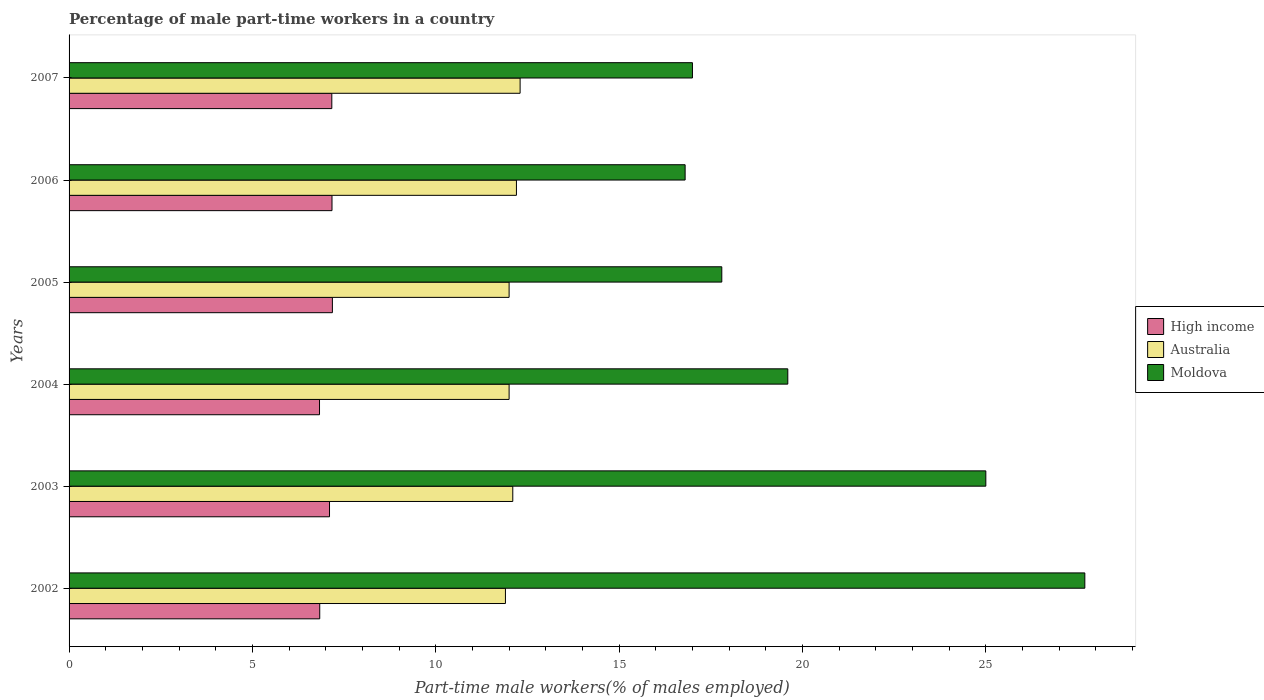How many different coloured bars are there?
Your response must be concise. 3. How many groups of bars are there?
Make the answer very short. 6. Are the number of bars on each tick of the Y-axis equal?
Give a very brief answer. Yes. How many bars are there on the 2nd tick from the bottom?
Give a very brief answer. 3. What is the label of the 3rd group of bars from the top?
Ensure brevity in your answer.  2005. In how many cases, is the number of bars for a given year not equal to the number of legend labels?
Provide a short and direct response. 0. What is the percentage of male part-time workers in Moldova in 2002?
Your answer should be very brief. 27.7. Across all years, what is the maximum percentage of male part-time workers in Moldova?
Your answer should be very brief. 27.7. Across all years, what is the minimum percentage of male part-time workers in Australia?
Keep it short and to the point. 11.9. What is the total percentage of male part-time workers in High income in the graph?
Provide a succinct answer. 42.28. What is the difference between the percentage of male part-time workers in High income in 2002 and that in 2005?
Provide a succinct answer. -0.34. What is the difference between the percentage of male part-time workers in Moldova in 2005 and the percentage of male part-time workers in High income in 2003?
Ensure brevity in your answer.  10.7. What is the average percentage of male part-time workers in Moldova per year?
Ensure brevity in your answer.  20.65. In the year 2002, what is the difference between the percentage of male part-time workers in Australia and percentage of male part-time workers in High income?
Provide a short and direct response. 5.06. In how many years, is the percentage of male part-time workers in Moldova greater than 23 %?
Your answer should be very brief. 2. What is the ratio of the percentage of male part-time workers in High income in 2005 to that in 2006?
Ensure brevity in your answer.  1. Is the difference between the percentage of male part-time workers in Australia in 2003 and 2007 greater than the difference between the percentage of male part-time workers in High income in 2003 and 2007?
Your response must be concise. No. What is the difference between the highest and the second highest percentage of male part-time workers in Moldova?
Your answer should be very brief. 2.7. What is the difference between the highest and the lowest percentage of male part-time workers in Moldova?
Your answer should be compact. 10.9. What does the 2nd bar from the bottom in 2007 represents?
Your response must be concise. Australia. How many bars are there?
Your answer should be compact. 18. Are all the bars in the graph horizontal?
Your answer should be compact. Yes. Are the values on the major ticks of X-axis written in scientific E-notation?
Ensure brevity in your answer.  No. Does the graph contain any zero values?
Offer a very short reply. No. Where does the legend appear in the graph?
Your answer should be very brief. Center right. How are the legend labels stacked?
Offer a terse response. Vertical. What is the title of the graph?
Your answer should be compact. Percentage of male part-time workers in a country. Does "Arab World" appear as one of the legend labels in the graph?
Give a very brief answer. No. What is the label or title of the X-axis?
Your answer should be very brief. Part-time male workers(% of males employed). What is the label or title of the Y-axis?
Your response must be concise. Years. What is the Part-time male workers(% of males employed) of High income in 2002?
Ensure brevity in your answer.  6.84. What is the Part-time male workers(% of males employed) in Australia in 2002?
Provide a succinct answer. 11.9. What is the Part-time male workers(% of males employed) of Moldova in 2002?
Your answer should be compact. 27.7. What is the Part-time male workers(% of males employed) of High income in 2003?
Your answer should be very brief. 7.1. What is the Part-time male workers(% of males employed) of Australia in 2003?
Ensure brevity in your answer.  12.1. What is the Part-time male workers(% of males employed) of Moldova in 2003?
Provide a short and direct response. 25. What is the Part-time male workers(% of males employed) of High income in 2004?
Give a very brief answer. 6.83. What is the Part-time male workers(% of males employed) in Australia in 2004?
Your answer should be very brief. 12. What is the Part-time male workers(% of males employed) of Moldova in 2004?
Your answer should be very brief. 19.6. What is the Part-time male workers(% of males employed) in High income in 2005?
Make the answer very short. 7.18. What is the Part-time male workers(% of males employed) of Australia in 2005?
Ensure brevity in your answer.  12. What is the Part-time male workers(% of males employed) in Moldova in 2005?
Provide a succinct answer. 17.8. What is the Part-time male workers(% of males employed) of High income in 2006?
Give a very brief answer. 7.17. What is the Part-time male workers(% of males employed) in Australia in 2006?
Provide a succinct answer. 12.2. What is the Part-time male workers(% of males employed) in Moldova in 2006?
Make the answer very short. 16.8. What is the Part-time male workers(% of males employed) of High income in 2007?
Make the answer very short. 7.16. What is the Part-time male workers(% of males employed) in Australia in 2007?
Keep it short and to the point. 12.3. Across all years, what is the maximum Part-time male workers(% of males employed) in High income?
Offer a very short reply. 7.18. Across all years, what is the maximum Part-time male workers(% of males employed) in Australia?
Your answer should be compact. 12.3. Across all years, what is the maximum Part-time male workers(% of males employed) in Moldova?
Your response must be concise. 27.7. Across all years, what is the minimum Part-time male workers(% of males employed) of High income?
Provide a short and direct response. 6.83. Across all years, what is the minimum Part-time male workers(% of males employed) of Australia?
Give a very brief answer. 11.9. Across all years, what is the minimum Part-time male workers(% of males employed) of Moldova?
Make the answer very short. 16.8. What is the total Part-time male workers(% of males employed) in High income in the graph?
Give a very brief answer. 42.28. What is the total Part-time male workers(% of males employed) in Australia in the graph?
Provide a short and direct response. 72.5. What is the total Part-time male workers(% of males employed) in Moldova in the graph?
Ensure brevity in your answer.  123.9. What is the difference between the Part-time male workers(% of males employed) of High income in 2002 and that in 2003?
Keep it short and to the point. -0.27. What is the difference between the Part-time male workers(% of males employed) in Australia in 2002 and that in 2003?
Ensure brevity in your answer.  -0.2. What is the difference between the Part-time male workers(% of males employed) in High income in 2002 and that in 2004?
Your response must be concise. 0.01. What is the difference between the Part-time male workers(% of males employed) in Australia in 2002 and that in 2004?
Offer a terse response. -0.1. What is the difference between the Part-time male workers(% of males employed) in High income in 2002 and that in 2005?
Offer a very short reply. -0.34. What is the difference between the Part-time male workers(% of males employed) in Australia in 2002 and that in 2005?
Your answer should be compact. -0.1. What is the difference between the Part-time male workers(% of males employed) of Moldova in 2002 and that in 2005?
Offer a terse response. 9.9. What is the difference between the Part-time male workers(% of males employed) in High income in 2002 and that in 2006?
Provide a succinct answer. -0.33. What is the difference between the Part-time male workers(% of males employed) in Australia in 2002 and that in 2006?
Make the answer very short. -0.3. What is the difference between the Part-time male workers(% of males employed) in High income in 2002 and that in 2007?
Your response must be concise. -0.33. What is the difference between the Part-time male workers(% of males employed) in Australia in 2002 and that in 2007?
Your answer should be compact. -0.4. What is the difference between the Part-time male workers(% of males employed) of Moldova in 2002 and that in 2007?
Offer a very short reply. 10.7. What is the difference between the Part-time male workers(% of males employed) of High income in 2003 and that in 2004?
Make the answer very short. 0.27. What is the difference between the Part-time male workers(% of males employed) in Australia in 2003 and that in 2004?
Keep it short and to the point. 0.1. What is the difference between the Part-time male workers(% of males employed) in Moldova in 2003 and that in 2004?
Make the answer very short. 5.4. What is the difference between the Part-time male workers(% of males employed) in High income in 2003 and that in 2005?
Keep it short and to the point. -0.08. What is the difference between the Part-time male workers(% of males employed) in Australia in 2003 and that in 2005?
Offer a terse response. 0.1. What is the difference between the Part-time male workers(% of males employed) of Moldova in 2003 and that in 2005?
Give a very brief answer. 7.2. What is the difference between the Part-time male workers(% of males employed) of High income in 2003 and that in 2006?
Keep it short and to the point. -0.07. What is the difference between the Part-time male workers(% of males employed) of High income in 2003 and that in 2007?
Your answer should be compact. -0.06. What is the difference between the Part-time male workers(% of males employed) in High income in 2004 and that in 2005?
Make the answer very short. -0.35. What is the difference between the Part-time male workers(% of males employed) of Moldova in 2004 and that in 2005?
Your response must be concise. 1.8. What is the difference between the Part-time male workers(% of males employed) in High income in 2004 and that in 2006?
Make the answer very short. -0.34. What is the difference between the Part-time male workers(% of males employed) in Australia in 2004 and that in 2006?
Your response must be concise. -0.2. What is the difference between the Part-time male workers(% of males employed) of High income in 2004 and that in 2007?
Ensure brevity in your answer.  -0.34. What is the difference between the Part-time male workers(% of males employed) of Australia in 2004 and that in 2007?
Offer a very short reply. -0.3. What is the difference between the Part-time male workers(% of males employed) in High income in 2005 and that in 2006?
Offer a terse response. 0.01. What is the difference between the Part-time male workers(% of males employed) in Moldova in 2005 and that in 2006?
Your response must be concise. 1. What is the difference between the Part-time male workers(% of males employed) in High income in 2005 and that in 2007?
Give a very brief answer. 0.02. What is the difference between the Part-time male workers(% of males employed) in High income in 2006 and that in 2007?
Provide a short and direct response. 0.01. What is the difference between the Part-time male workers(% of males employed) in High income in 2002 and the Part-time male workers(% of males employed) in Australia in 2003?
Your response must be concise. -5.26. What is the difference between the Part-time male workers(% of males employed) of High income in 2002 and the Part-time male workers(% of males employed) of Moldova in 2003?
Offer a terse response. -18.16. What is the difference between the Part-time male workers(% of males employed) of High income in 2002 and the Part-time male workers(% of males employed) of Australia in 2004?
Keep it short and to the point. -5.16. What is the difference between the Part-time male workers(% of males employed) of High income in 2002 and the Part-time male workers(% of males employed) of Moldova in 2004?
Give a very brief answer. -12.76. What is the difference between the Part-time male workers(% of males employed) in High income in 2002 and the Part-time male workers(% of males employed) in Australia in 2005?
Ensure brevity in your answer.  -5.16. What is the difference between the Part-time male workers(% of males employed) in High income in 2002 and the Part-time male workers(% of males employed) in Moldova in 2005?
Keep it short and to the point. -10.96. What is the difference between the Part-time male workers(% of males employed) in High income in 2002 and the Part-time male workers(% of males employed) in Australia in 2006?
Offer a terse response. -5.36. What is the difference between the Part-time male workers(% of males employed) of High income in 2002 and the Part-time male workers(% of males employed) of Moldova in 2006?
Your answer should be compact. -9.96. What is the difference between the Part-time male workers(% of males employed) in Australia in 2002 and the Part-time male workers(% of males employed) in Moldova in 2006?
Keep it short and to the point. -4.9. What is the difference between the Part-time male workers(% of males employed) of High income in 2002 and the Part-time male workers(% of males employed) of Australia in 2007?
Ensure brevity in your answer.  -5.46. What is the difference between the Part-time male workers(% of males employed) in High income in 2002 and the Part-time male workers(% of males employed) in Moldova in 2007?
Provide a succinct answer. -10.16. What is the difference between the Part-time male workers(% of males employed) of High income in 2003 and the Part-time male workers(% of males employed) of Australia in 2004?
Keep it short and to the point. -4.9. What is the difference between the Part-time male workers(% of males employed) of High income in 2003 and the Part-time male workers(% of males employed) of Moldova in 2004?
Offer a very short reply. -12.5. What is the difference between the Part-time male workers(% of males employed) of High income in 2003 and the Part-time male workers(% of males employed) of Australia in 2005?
Make the answer very short. -4.9. What is the difference between the Part-time male workers(% of males employed) of High income in 2003 and the Part-time male workers(% of males employed) of Moldova in 2005?
Your answer should be compact. -10.7. What is the difference between the Part-time male workers(% of males employed) in Australia in 2003 and the Part-time male workers(% of males employed) in Moldova in 2005?
Keep it short and to the point. -5.7. What is the difference between the Part-time male workers(% of males employed) of High income in 2003 and the Part-time male workers(% of males employed) of Australia in 2006?
Provide a short and direct response. -5.1. What is the difference between the Part-time male workers(% of males employed) of High income in 2003 and the Part-time male workers(% of males employed) of Moldova in 2006?
Your answer should be very brief. -9.7. What is the difference between the Part-time male workers(% of males employed) of Australia in 2003 and the Part-time male workers(% of males employed) of Moldova in 2006?
Make the answer very short. -4.7. What is the difference between the Part-time male workers(% of males employed) of High income in 2003 and the Part-time male workers(% of males employed) of Australia in 2007?
Your answer should be compact. -5.2. What is the difference between the Part-time male workers(% of males employed) in High income in 2003 and the Part-time male workers(% of males employed) in Moldova in 2007?
Give a very brief answer. -9.9. What is the difference between the Part-time male workers(% of males employed) of Australia in 2003 and the Part-time male workers(% of males employed) of Moldova in 2007?
Ensure brevity in your answer.  -4.9. What is the difference between the Part-time male workers(% of males employed) of High income in 2004 and the Part-time male workers(% of males employed) of Australia in 2005?
Your answer should be very brief. -5.17. What is the difference between the Part-time male workers(% of males employed) of High income in 2004 and the Part-time male workers(% of males employed) of Moldova in 2005?
Give a very brief answer. -10.97. What is the difference between the Part-time male workers(% of males employed) in Australia in 2004 and the Part-time male workers(% of males employed) in Moldova in 2005?
Provide a short and direct response. -5.8. What is the difference between the Part-time male workers(% of males employed) of High income in 2004 and the Part-time male workers(% of males employed) of Australia in 2006?
Offer a terse response. -5.37. What is the difference between the Part-time male workers(% of males employed) in High income in 2004 and the Part-time male workers(% of males employed) in Moldova in 2006?
Offer a very short reply. -9.97. What is the difference between the Part-time male workers(% of males employed) in High income in 2004 and the Part-time male workers(% of males employed) in Australia in 2007?
Give a very brief answer. -5.47. What is the difference between the Part-time male workers(% of males employed) of High income in 2004 and the Part-time male workers(% of males employed) of Moldova in 2007?
Provide a short and direct response. -10.17. What is the difference between the Part-time male workers(% of males employed) of Australia in 2004 and the Part-time male workers(% of males employed) of Moldova in 2007?
Provide a succinct answer. -5. What is the difference between the Part-time male workers(% of males employed) in High income in 2005 and the Part-time male workers(% of males employed) in Australia in 2006?
Ensure brevity in your answer.  -5.02. What is the difference between the Part-time male workers(% of males employed) in High income in 2005 and the Part-time male workers(% of males employed) in Moldova in 2006?
Keep it short and to the point. -9.62. What is the difference between the Part-time male workers(% of males employed) in High income in 2005 and the Part-time male workers(% of males employed) in Australia in 2007?
Your response must be concise. -5.12. What is the difference between the Part-time male workers(% of males employed) in High income in 2005 and the Part-time male workers(% of males employed) in Moldova in 2007?
Provide a succinct answer. -9.82. What is the difference between the Part-time male workers(% of males employed) of Australia in 2005 and the Part-time male workers(% of males employed) of Moldova in 2007?
Make the answer very short. -5. What is the difference between the Part-time male workers(% of males employed) of High income in 2006 and the Part-time male workers(% of males employed) of Australia in 2007?
Offer a very short reply. -5.13. What is the difference between the Part-time male workers(% of males employed) of High income in 2006 and the Part-time male workers(% of males employed) of Moldova in 2007?
Offer a very short reply. -9.83. What is the average Part-time male workers(% of males employed) of High income per year?
Offer a very short reply. 7.05. What is the average Part-time male workers(% of males employed) in Australia per year?
Provide a succinct answer. 12.08. What is the average Part-time male workers(% of males employed) of Moldova per year?
Offer a terse response. 20.65. In the year 2002, what is the difference between the Part-time male workers(% of males employed) of High income and Part-time male workers(% of males employed) of Australia?
Provide a succinct answer. -5.06. In the year 2002, what is the difference between the Part-time male workers(% of males employed) in High income and Part-time male workers(% of males employed) in Moldova?
Keep it short and to the point. -20.86. In the year 2002, what is the difference between the Part-time male workers(% of males employed) of Australia and Part-time male workers(% of males employed) of Moldova?
Your answer should be very brief. -15.8. In the year 2003, what is the difference between the Part-time male workers(% of males employed) in High income and Part-time male workers(% of males employed) in Australia?
Offer a terse response. -5. In the year 2003, what is the difference between the Part-time male workers(% of males employed) in High income and Part-time male workers(% of males employed) in Moldova?
Give a very brief answer. -17.9. In the year 2004, what is the difference between the Part-time male workers(% of males employed) of High income and Part-time male workers(% of males employed) of Australia?
Provide a short and direct response. -5.17. In the year 2004, what is the difference between the Part-time male workers(% of males employed) of High income and Part-time male workers(% of males employed) of Moldova?
Your response must be concise. -12.77. In the year 2004, what is the difference between the Part-time male workers(% of males employed) in Australia and Part-time male workers(% of males employed) in Moldova?
Keep it short and to the point. -7.6. In the year 2005, what is the difference between the Part-time male workers(% of males employed) in High income and Part-time male workers(% of males employed) in Australia?
Give a very brief answer. -4.82. In the year 2005, what is the difference between the Part-time male workers(% of males employed) of High income and Part-time male workers(% of males employed) of Moldova?
Provide a short and direct response. -10.62. In the year 2005, what is the difference between the Part-time male workers(% of males employed) of Australia and Part-time male workers(% of males employed) of Moldova?
Offer a very short reply. -5.8. In the year 2006, what is the difference between the Part-time male workers(% of males employed) in High income and Part-time male workers(% of males employed) in Australia?
Make the answer very short. -5.03. In the year 2006, what is the difference between the Part-time male workers(% of males employed) in High income and Part-time male workers(% of males employed) in Moldova?
Offer a very short reply. -9.63. In the year 2007, what is the difference between the Part-time male workers(% of males employed) of High income and Part-time male workers(% of males employed) of Australia?
Keep it short and to the point. -5.13. In the year 2007, what is the difference between the Part-time male workers(% of males employed) in High income and Part-time male workers(% of males employed) in Moldova?
Your response must be concise. -9.84. In the year 2007, what is the difference between the Part-time male workers(% of males employed) of Australia and Part-time male workers(% of males employed) of Moldova?
Your answer should be very brief. -4.7. What is the ratio of the Part-time male workers(% of males employed) of High income in 2002 to that in 2003?
Make the answer very short. 0.96. What is the ratio of the Part-time male workers(% of males employed) in Australia in 2002 to that in 2003?
Your response must be concise. 0.98. What is the ratio of the Part-time male workers(% of males employed) of Moldova in 2002 to that in 2003?
Your response must be concise. 1.11. What is the ratio of the Part-time male workers(% of males employed) in High income in 2002 to that in 2004?
Make the answer very short. 1. What is the ratio of the Part-time male workers(% of males employed) of Moldova in 2002 to that in 2004?
Make the answer very short. 1.41. What is the ratio of the Part-time male workers(% of males employed) in High income in 2002 to that in 2005?
Your answer should be very brief. 0.95. What is the ratio of the Part-time male workers(% of males employed) in Australia in 2002 to that in 2005?
Your response must be concise. 0.99. What is the ratio of the Part-time male workers(% of males employed) in Moldova in 2002 to that in 2005?
Keep it short and to the point. 1.56. What is the ratio of the Part-time male workers(% of males employed) of High income in 2002 to that in 2006?
Your answer should be compact. 0.95. What is the ratio of the Part-time male workers(% of males employed) in Australia in 2002 to that in 2006?
Make the answer very short. 0.98. What is the ratio of the Part-time male workers(% of males employed) of Moldova in 2002 to that in 2006?
Offer a very short reply. 1.65. What is the ratio of the Part-time male workers(% of males employed) in High income in 2002 to that in 2007?
Provide a short and direct response. 0.95. What is the ratio of the Part-time male workers(% of males employed) in Australia in 2002 to that in 2007?
Give a very brief answer. 0.97. What is the ratio of the Part-time male workers(% of males employed) of Moldova in 2002 to that in 2007?
Your answer should be compact. 1.63. What is the ratio of the Part-time male workers(% of males employed) in High income in 2003 to that in 2004?
Your response must be concise. 1.04. What is the ratio of the Part-time male workers(% of males employed) in Australia in 2003 to that in 2004?
Offer a terse response. 1.01. What is the ratio of the Part-time male workers(% of males employed) of Moldova in 2003 to that in 2004?
Offer a terse response. 1.28. What is the ratio of the Part-time male workers(% of males employed) in High income in 2003 to that in 2005?
Provide a succinct answer. 0.99. What is the ratio of the Part-time male workers(% of males employed) in Australia in 2003 to that in 2005?
Your response must be concise. 1.01. What is the ratio of the Part-time male workers(% of males employed) in Moldova in 2003 to that in 2005?
Provide a short and direct response. 1.4. What is the ratio of the Part-time male workers(% of males employed) of High income in 2003 to that in 2006?
Your answer should be compact. 0.99. What is the ratio of the Part-time male workers(% of males employed) of Moldova in 2003 to that in 2006?
Provide a succinct answer. 1.49. What is the ratio of the Part-time male workers(% of males employed) in Australia in 2003 to that in 2007?
Ensure brevity in your answer.  0.98. What is the ratio of the Part-time male workers(% of males employed) in Moldova in 2003 to that in 2007?
Give a very brief answer. 1.47. What is the ratio of the Part-time male workers(% of males employed) of High income in 2004 to that in 2005?
Provide a short and direct response. 0.95. What is the ratio of the Part-time male workers(% of males employed) of Moldova in 2004 to that in 2005?
Offer a terse response. 1.1. What is the ratio of the Part-time male workers(% of males employed) of High income in 2004 to that in 2006?
Give a very brief answer. 0.95. What is the ratio of the Part-time male workers(% of males employed) in Australia in 2004 to that in 2006?
Offer a very short reply. 0.98. What is the ratio of the Part-time male workers(% of males employed) of High income in 2004 to that in 2007?
Your answer should be very brief. 0.95. What is the ratio of the Part-time male workers(% of males employed) in Australia in 2004 to that in 2007?
Your answer should be very brief. 0.98. What is the ratio of the Part-time male workers(% of males employed) of Moldova in 2004 to that in 2007?
Provide a short and direct response. 1.15. What is the ratio of the Part-time male workers(% of males employed) in Australia in 2005 to that in 2006?
Your answer should be compact. 0.98. What is the ratio of the Part-time male workers(% of males employed) in Moldova in 2005 to that in 2006?
Offer a terse response. 1.06. What is the ratio of the Part-time male workers(% of males employed) of Australia in 2005 to that in 2007?
Your answer should be very brief. 0.98. What is the ratio of the Part-time male workers(% of males employed) in Moldova in 2005 to that in 2007?
Make the answer very short. 1.05. What is the ratio of the Part-time male workers(% of males employed) of High income in 2006 to that in 2007?
Give a very brief answer. 1. What is the ratio of the Part-time male workers(% of males employed) of Australia in 2006 to that in 2007?
Make the answer very short. 0.99. What is the difference between the highest and the second highest Part-time male workers(% of males employed) in High income?
Give a very brief answer. 0.01. What is the difference between the highest and the lowest Part-time male workers(% of males employed) of High income?
Provide a succinct answer. 0.35. What is the difference between the highest and the lowest Part-time male workers(% of males employed) of Australia?
Provide a short and direct response. 0.4. 